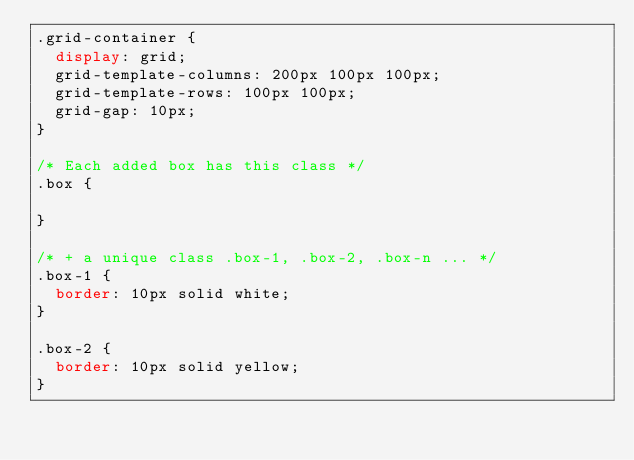<code> <loc_0><loc_0><loc_500><loc_500><_CSS_>.grid-container {
  display: grid;
  grid-template-columns: 200px 100px 100px;
  grid-template-rows: 100px 100px;
  grid-gap: 10px;
}

/* Each added box has this class */
.box {
  
}

/* + a unique class .box-1, .box-2, .box-n ... */
.box-1 {
  border: 10px solid white;
}

.box-2 {
  border: 10px solid yellow;
}</code> 